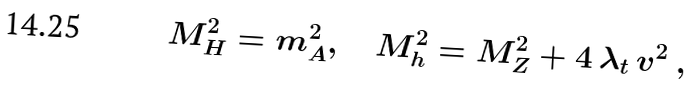<formula> <loc_0><loc_0><loc_500><loc_500>M _ { H } ^ { 2 } = m _ { A } ^ { 2 } , \quad M _ { h } ^ { 2 } = M _ { Z } ^ { 2 } + 4 \, \lambda _ { t } \, v ^ { 2 } \ ,</formula> 